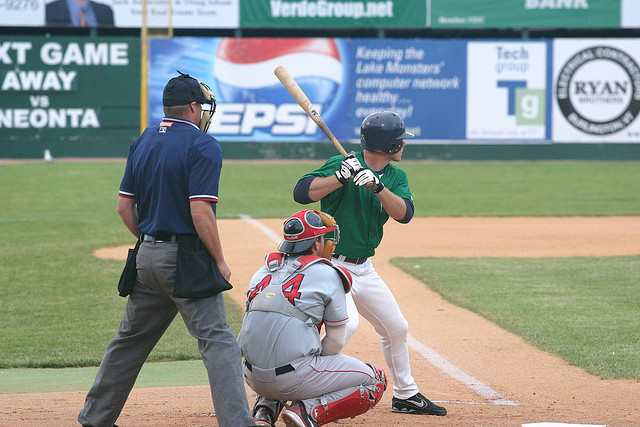Please extract the text content from this image. KT GAME AWAY NEONTA VS EPSI RYAN Tech VerdeGroup.net Tg 44 